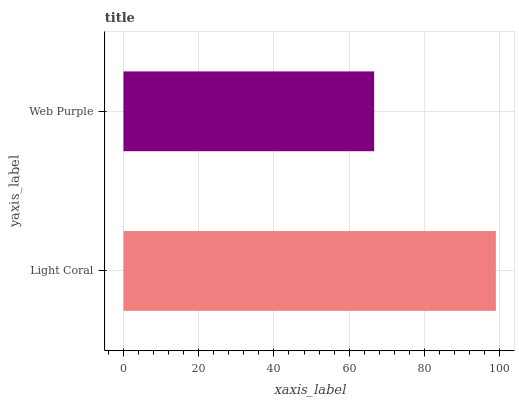Is Web Purple the minimum?
Answer yes or no. Yes. Is Light Coral the maximum?
Answer yes or no. Yes. Is Web Purple the maximum?
Answer yes or no. No. Is Light Coral greater than Web Purple?
Answer yes or no. Yes. Is Web Purple less than Light Coral?
Answer yes or no. Yes. Is Web Purple greater than Light Coral?
Answer yes or no. No. Is Light Coral less than Web Purple?
Answer yes or no. No. Is Light Coral the high median?
Answer yes or no. Yes. Is Web Purple the low median?
Answer yes or no. Yes. Is Web Purple the high median?
Answer yes or no. No. Is Light Coral the low median?
Answer yes or no. No. 